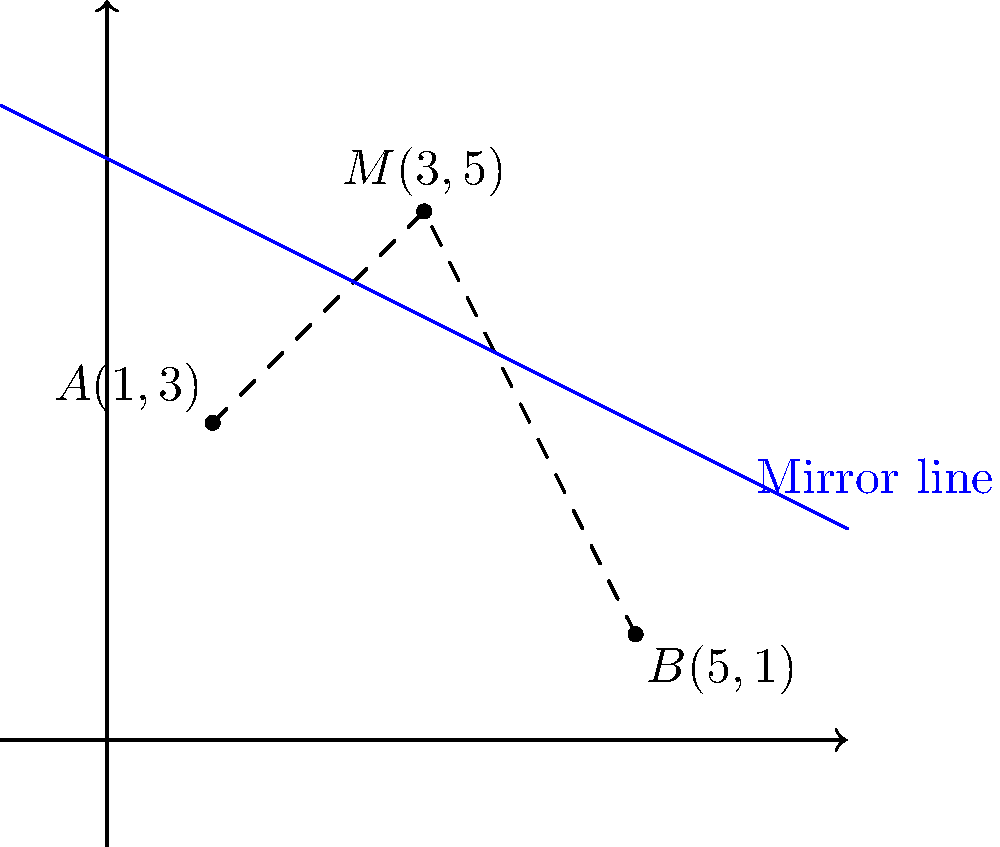In a photo editing session, you're working with a mirrored image effect. Point $A(1,3)$ represents a feature in the original image, and point $M(3,5)$ is on the mirror line. If point $B$ is the reflection of $A$ across the mirror line, what are the coordinates of point $B$? To find the coordinates of point $B$, we can follow these steps:

1) The mirror line passes through point $M(3,5)$ and is perpendicular to line $AM$.

2) The midpoint of $AB$ lies on the mirror line. Since we know $M$ is on the mirror line, $M$ must be the midpoint of $AB$.

3) If $M(3,5)$ is the midpoint of $AB$, then:
   $$A_x + B_x = 2M_x \text{ and } A_y + B_y = 2M_y$$

4) We know $A(1,3)$ and $M(3,5)$, so:
   $$1 + B_x = 2(3) \text{ and } 3 + B_y = 2(5)$$

5) Solving these equations:
   $$B_x = 2(3) - 1 = 5$$
   $$B_y = 2(5) - 3 = 7$$

6) Therefore, the coordinates of point $B$ are $(5,7)$.

7) We can verify this result by checking if $(5,1)$ is indeed on the graph, which it is.
Answer: $B(5,7)$ 